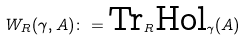Convert formula to latex. <formula><loc_0><loc_0><loc_500><loc_500>W _ { R } ( \gamma , A ) \colon = \text {Tr} _ { R } \text {Hol} _ { \gamma } ( A )</formula> 